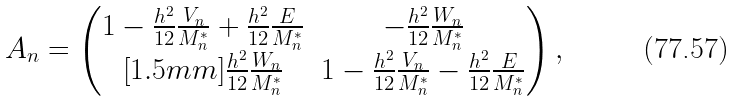Convert formula to latex. <formula><loc_0><loc_0><loc_500><loc_500>A _ { n } = \left ( \begin{matrix} 1 - \frac { h ^ { 2 } } { 1 2 } \frac { V _ { n } } { M ^ { * } _ { n } } + \frac { h ^ { 2 } } { 1 2 } \frac { E } { M ^ { * } _ { n } } & - \frac { h ^ { 2 } } { 1 2 } \frac { W _ { n } } { M ^ { * } _ { n } } \\ [ 1 . 5 m m ] \frac { h ^ { 2 } } { 1 2 } \frac { W _ { n } } { M ^ { * } _ { n } } & 1 - \frac { h ^ { 2 } } { 1 2 } \frac { V _ { n } } { M ^ { * } _ { n } } - \frac { h ^ { 2 } } { 1 2 } \frac { E } { M ^ { * } _ { n } } \\ \end{matrix} \right ) ,</formula> 